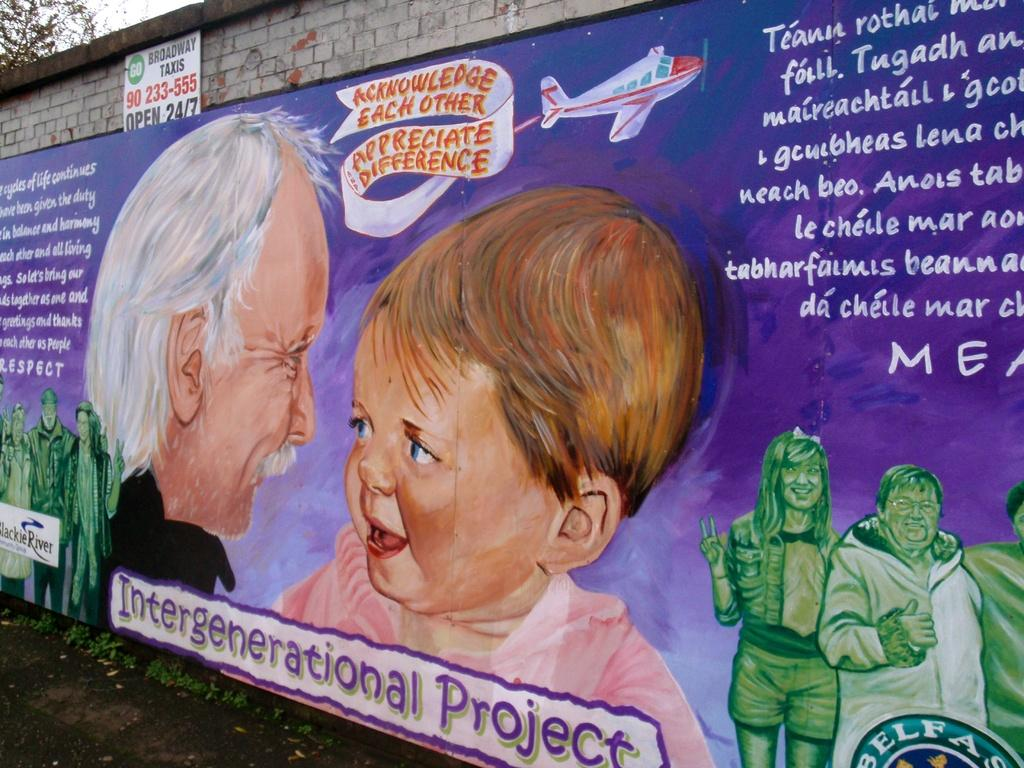What is the main object in the image? There is a banner in the image. What can be found on the banner? The banner has text written on it and images of persons. What is visible in the background of the image? There is a wall and a tree in the background of the image. What type of coal is being used to power the camera in the image? There is no camera or coal present in the image. 